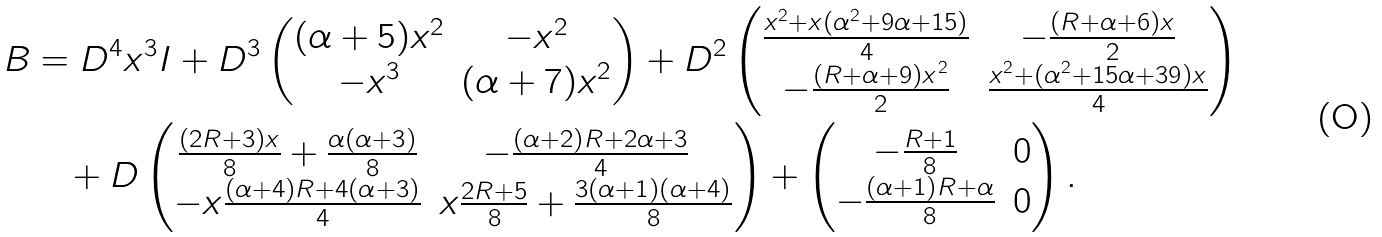<formula> <loc_0><loc_0><loc_500><loc_500>B & = D ^ { 4 } x ^ { 3 } I + D ^ { 3 } \begin{pmatrix} ( \alpha + 5 ) x ^ { 2 } & - x ^ { 2 } \\ - x ^ { 3 } & ( \alpha + 7 ) x ^ { 2 } \end{pmatrix} + D ^ { 2 } \begin{pmatrix} \frac { x ^ { 2 } + x ( \alpha ^ { 2 } + 9 \alpha + 1 5 ) } { 4 } & - \frac { ( R + \alpha + 6 ) x } { 2 } \\ - \frac { ( R + \alpha + 9 ) x ^ { 2 } } { 2 } & \frac { x ^ { 2 } + ( \alpha ^ { 2 } + 1 5 \alpha + 3 9 ) x } { 4 } \end{pmatrix} \\ & \quad + D \begin{pmatrix} \frac { ( 2 R + 3 ) x } { 8 } + \frac { \alpha ( \alpha + 3 ) } { 8 } & - \frac { ( \alpha + 2 ) R + 2 \alpha + 3 } { 4 } \\ - x \frac { ( \alpha + 4 ) R + 4 ( \alpha + 3 ) } { 4 } & x \frac { 2 R + 5 } { 8 } + \frac { 3 ( \alpha + 1 ) ( \alpha + 4 ) } { 8 } \end{pmatrix} + \begin{pmatrix} - \frac { R + 1 } { 8 } & 0 \\ - \frac { ( \alpha + 1 ) R + \alpha } { 8 } & 0 \end{pmatrix} .</formula> 